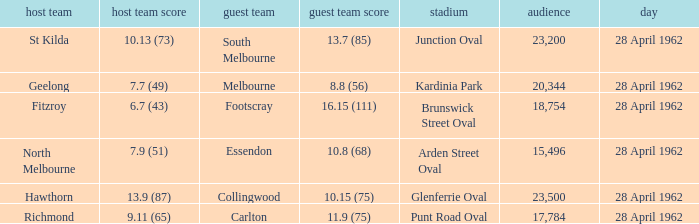What was the crowd size when there was a home team score of 10.13 (73)? 23200.0. 